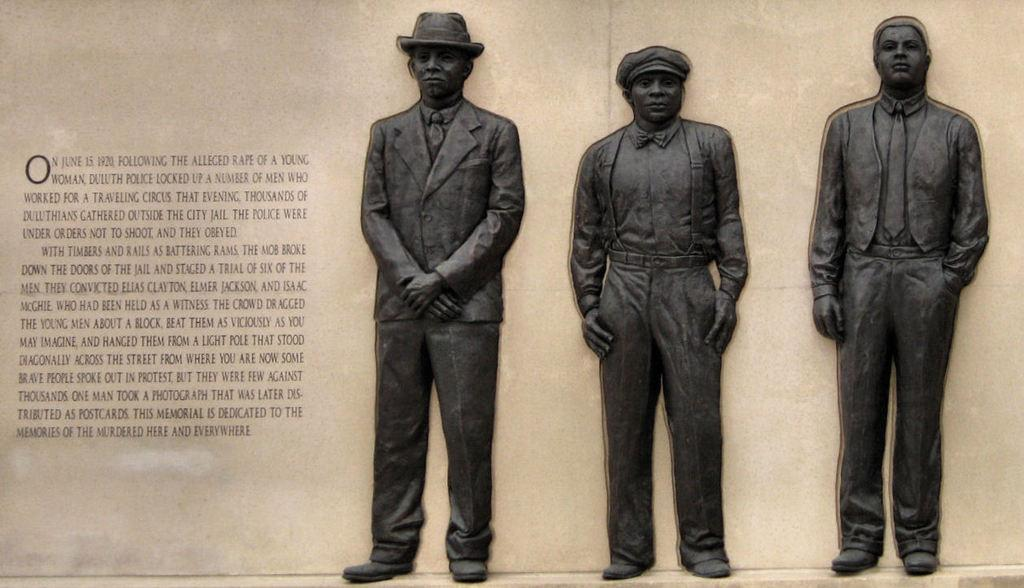What is depicted in the image? There are three statues of men in the image. Where are the statues located? The statues are standing on a platform. What else can be seen in the image besides the statues? There is text written on a wall in the image. On which side of the image is the text located? The text is on the right side of the image. Can you tell me how many balls are being juggled by the statues in the image? There are no balls or juggling depicted in the image; it features three statues of men standing on a platform with text on a wall. 